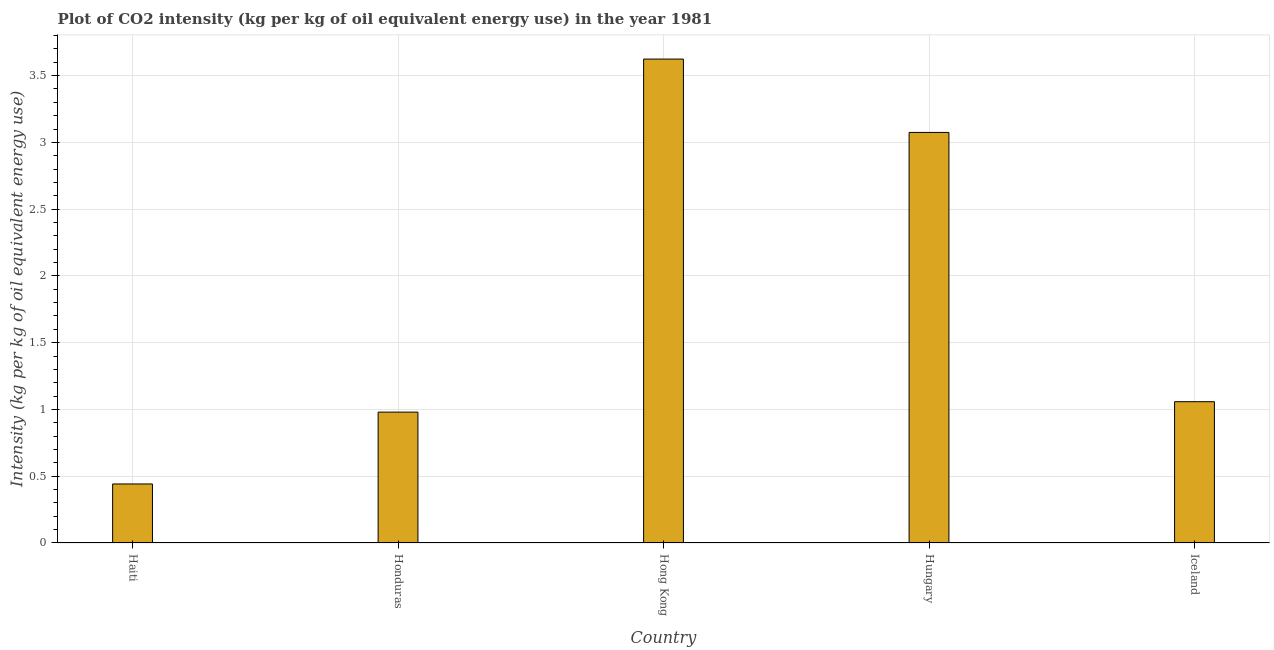Does the graph contain grids?
Your response must be concise. Yes. What is the title of the graph?
Make the answer very short. Plot of CO2 intensity (kg per kg of oil equivalent energy use) in the year 1981. What is the label or title of the X-axis?
Your response must be concise. Country. What is the label or title of the Y-axis?
Your response must be concise. Intensity (kg per kg of oil equivalent energy use). What is the co2 intensity in Haiti?
Make the answer very short. 0.44. Across all countries, what is the maximum co2 intensity?
Give a very brief answer. 3.62. Across all countries, what is the minimum co2 intensity?
Give a very brief answer. 0.44. In which country was the co2 intensity maximum?
Keep it short and to the point. Hong Kong. In which country was the co2 intensity minimum?
Provide a short and direct response. Haiti. What is the sum of the co2 intensity?
Your response must be concise. 9.18. What is the difference between the co2 intensity in Honduras and Hong Kong?
Keep it short and to the point. -2.64. What is the average co2 intensity per country?
Ensure brevity in your answer.  1.84. What is the median co2 intensity?
Your answer should be very brief. 1.06. What is the ratio of the co2 intensity in Haiti to that in Hungary?
Keep it short and to the point. 0.14. Is the co2 intensity in Honduras less than that in Iceland?
Offer a very short reply. Yes. Is the difference between the co2 intensity in Hong Kong and Hungary greater than the difference between any two countries?
Your response must be concise. No. What is the difference between the highest and the second highest co2 intensity?
Ensure brevity in your answer.  0.55. Is the sum of the co2 intensity in Haiti and Honduras greater than the maximum co2 intensity across all countries?
Provide a succinct answer. No. What is the difference between the highest and the lowest co2 intensity?
Offer a very short reply. 3.18. Are all the bars in the graph horizontal?
Make the answer very short. No. How many countries are there in the graph?
Your response must be concise. 5. What is the difference between two consecutive major ticks on the Y-axis?
Your response must be concise. 0.5. What is the Intensity (kg per kg of oil equivalent energy use) of Haiti?
Offer a terse response. 0.44. What is the Intensity (kg per kg of oil equivalent energy use) in Honduras?
Ensure brevity in your answer.  0.98. What is the Intensity (kg per kg of oil equivalent energy use) in Hong Kong?
Provide a short and direct response. 3.62. What is the Intensity (kg per kg of oil equivalent energy use) in Hungary?
Your response must be concise. 3.07. What is the Intensity (kg per kg of oil equivalent energy use) in Iceland?
Keep it short and to the point. 1.06. What is the difference between the Intensity (kg per kg of oil equivalent energy use) in Haiti and Honduras?
Your answer should be compact. -0.54. What is the difference between the Intensity (kg per kg of oil equivalent energy use) in Haiti and Hong Kong?
Provide a succinct answer. -3.18. What is the difference between the Intensity (kg per kg of oil equivalent energy use) in Haiti and Hungary?
Offer a very short reply. -2.63. What is the difference between the Intensity (kg per kg of oil equivalent energy use) in Haiti and Iceland?
Give a very brief answer. -0.62. What is the difference between the Intensity (kg per kg of oil equivalent energy use) in Honduras and Hong Kong?
Keep it short and to the point. -2.64. What is the difference between the Intensity (kg per kg of oil equivalent energy use) in Honduras and Hungary?
Provide a succinct answer. -2.09. What is the difference between the Intensity (kg per kg of oil equivalent energy use) in Honduras and Iceland?
Your response must be concise. -0.08. What is the difference between the Intensity (kg per kg of oil equivalent energy use) in Hong Kong and Hungary?
Provide a succinct answer. 0.55. What is the difference between the Intensity (kg per kg of oil equivalent energy use) in Hong Kong and Iceland?
Your answer should be compact. 2.57. What is the difference between the Intensity (kg per kg of oil equivalent energy use) in Hungary and Iceland?
Provide a short and direct response. 2.02. What is the ratio of the Intensity (kg per kg of oil equivalent energy use) in Haiti to that in Honduras?
Keep it short and to the point. 0.45. What is the ratio of the Intensity (kg per kg of oil equivalent energy use) in Haiti to that in Hong Kong?
Make the answer very short. 0.12. What is the ratio of the Intensity (kg per kg of oil equivalent energy use) in Haiti to that in Hungary?
Your answer should be very brief. 0.14. What is the ratio of the Intensity (kg per kg of oil equivalent energy use) in Haiti to that in Iceland?
Ensure brevity in your answer.  0.42. What is the ratio of the Intensity (kg per kg of oil equivalent energy use) in Honduras to that in Hong Kong?
Make the answer very short. 0.27. What is the ratio of the Intensity (kg per kg of oil equivalent energy use) in Honduras to that in Hungary?
Your answer should be compact. 0.32. What is the ratio of the Intensity (kg per kg of oil equivalent energy use) in Honduras to that in Iceland?
Your response must be concise. 0.93. What is the ratio of the Intensity (kg per kg of oil equivalent energy use) in Hong Kong to that in Hungary?
Keep it short and to the point. 1.18. What is the ratio of the Intensity (kg per kg of oil equivalent energy use) in Hong Kong to that in Iceland?
Offer a terse response. 3.42. What is the ratio of the Intensity (kg per kg of oil equivalent energy use) in Hungary to that in Iceland?
Provide a succinct answer. 2.91. 